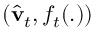Convert formula to latex. <formula><loc_0><loc_0><loc_500><loc_500>( \widehat { v } _ { t } , f _ { t } ( . ) )</formula> 